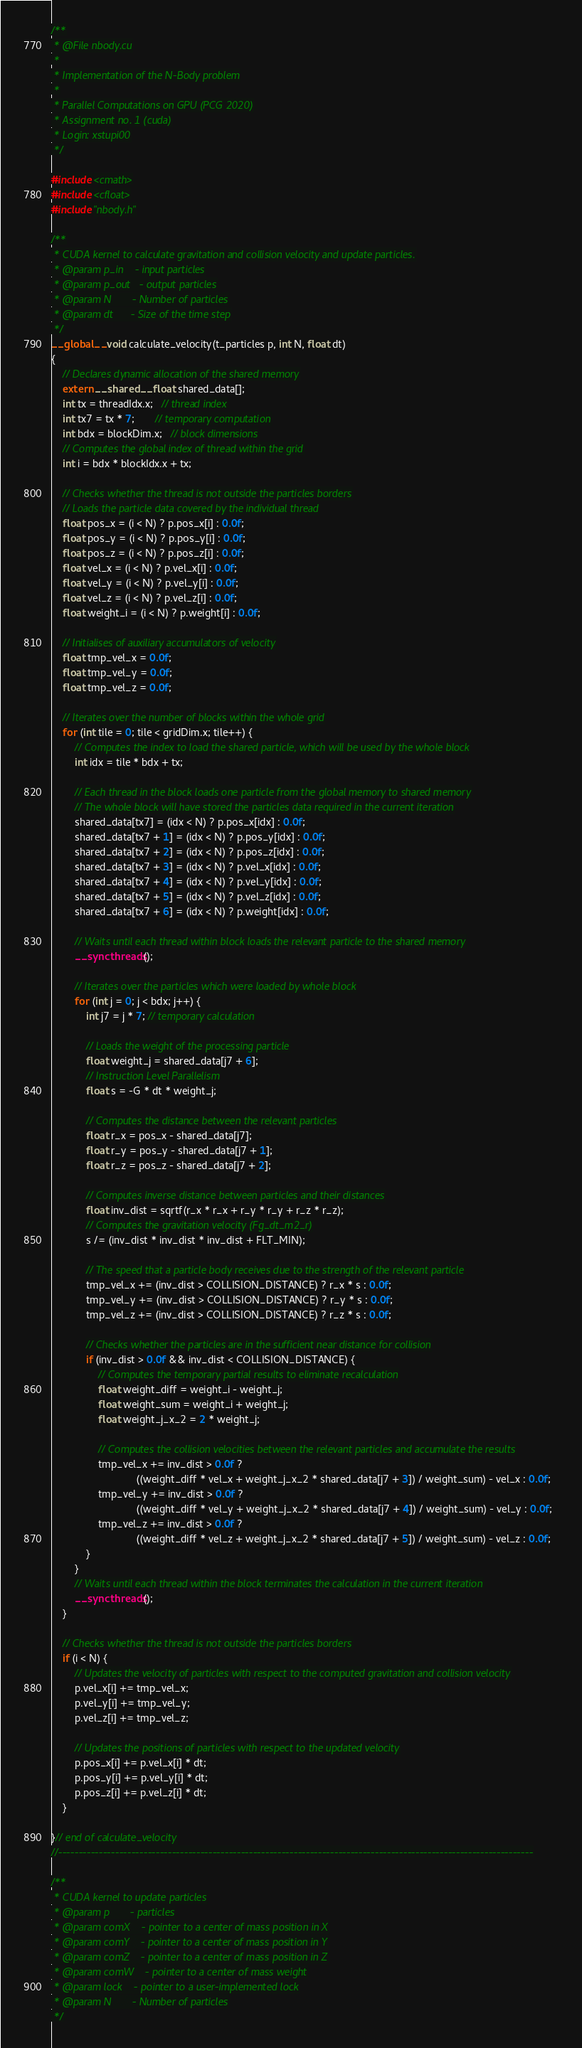Convert code to text. <code><loc_0><loc_0><loc_500><loc_500><_Cuda_>/**
 * @File nbody.cu
 *
 * Implementation of the N-Body problem
 *
 * Parallel Computations on GPU (PCG 2020)
 * Assignment no. 1 (cuda)
 * Login: xstupi00
 */

#include <cmath>
#include <cfloat>
#include "nbody.h"

/**
 * CUDA kernel to calculate gravitation and collision velocity and update particles.
 * @param p_in    - input particles
 * @param p_out   - output particles
 * @param N       - Number of particles
 * @param dt      - Size of the time step
 */
__global__ void calculate_velocity(t_particles p, int N, float dt)
{
    // Declares dynamic allocation of the shared memory
    extern __shared__ float shared_data[];
    int tx = threadIdx.x;   // thread index
    int tx7 = tx * 7;       // temporary computation
    int bdx = blockDim.x;   // block dimensions
    // Computes the global index of thread within the grid
    int i = bdx * blockIdx.x + tx;

    // Checks whether the thread is not outside the particles borders
    // Loads the particle data covered by the individual thread
    float pos_x = (i < N) ? p.pos_x[i] : 0.0f;
    float pos_y = (i < N) ? p.pos_y[i] : 0.0f;
    float pos_z = (i < N) ? p.pos_z[i] : 0.0f;
    float vel_x = (i < N) ? p.vel_x[i] : 0.0f;
    float vel_y = (i < N) ? p.vel_y[i] : 0.0f;
    float vel_z = (i < N) ? p.vel_z[i] : 0.0f;
    float weight_i = (i < N) ? p.weight[i] : 0.0f;

    // Initialises of auxiliary accumulators of velocity
    float tmp_vel_x = 0.0f;
    float tmp_vel_y = 0.0f;
    float tmp_vel_z = 0.0f;

    // Iterates over the number of blocks within the whole grid
    for (int tile = 0; tile < gridDim.x; tile++) {
        // Computes the index to load the shared particle, which will be used by the whole block
        int idx = tile * bdx + tx;

        // Each thread in the block loads one particle from the global memory to shared memory
        // The whole block will have stored the particles data required in the current iteration
        shared_data[tx7] = (idx < N) ? p.pos_x[idx] : 0.0f;
        shared_data[tx7 + 1] = (idx < N) ? p.pos_y[idx] : 0.0f;
        shared_data[tx7 + 2] = (idx < N) ? p.pos_z[idx] : 0.0f;
        shared_data[tx7 + 3] = (idx < N) ? p.vel_x[idx] : 0.0f;
        shared_data[tx7 + 4] = (idx < N) ? p.vel_y[idx] : 0.0f;
        shared_data[tx7 + 5] = (idx < N) ? p.vel_z[idx] : 0.0f;
        shared_data[tx7 + 6] = (idx < N) ? p.weight[idx] : 0.0f;

        // Waits until each thread within block loads the relevant particle to the shared memory
        __syncthreads();

        // Iterates over the particles which were loaded by whole block
        for (int j = 0; j < bdx; j++) {
            int j7 = j * 7; // temporary calculation

            // Loads the weight of the processing particle
            float weight_j = shared_data[j7 + 6];
            // Instruction Level Parallelism
            float s = -G * dt * weight_j;

            // Computes the distance between the relevant particles
            float r_x = pos_x - shared_data[j7];
            float r_y = pos_y - shared_data[j7 + 1];
            float r_z = pos_z - shared_data[j7 + 2];

            // Computes inverse distance between particles and their distances
            float inv_dist = sqrtf(r_x * r_x + r_y * r_y + r_z * r_z);
            // Computes the gravitation velocity (Fg_dt_m2_r)
            s /= (inv_dist * inv_dist * inv_dist + FLT_MIN);

            // The speed that a particle body receives due to the strength of the relevant particle
            tmp_vel_x += (inv_dist > COLLISION_DISTANCE) ? r_x * s : 0.0f;
            tmp_vel_y += (inv_dist > COLLISION_DISTANCE) ? r_y * s : 0.0f;
            tmp_vel_z += (inv_dist > COLLISION_DISTANCE) ? r_z * s : 0.0f;

            // Checks whether the particles are in the sufficient near distance for collision
            if (inv_dist > 0.0f && inv_dist < COLLISION_DISTANCE) {
                // Computes the temporary partial results to eliminate recalculation
                float weight_diff = weight_i - weight_j;
                float weight_sum = weight_i + weight_j;
                float weight_j_x_2 = 2 * weight_j;

                // Computes the collision velocities between the relevant particles and accumulate the results
                tmp_vel_x += inv_dist > 0.0f ?
                             ((weight_diff * vel_x + weight_j_x_2 * shared_data[j7 + 3]) / weight_sum) - vel_x : 0.0f;
                tmp_vel_y += inv_dist > 0.0f ?
                             ((weight_diff * vel_y + weight_j_x_2 * shared_data[j7 + 4]) / weight_sum) - vel_y : 0.0f;
                tmp_vel_z += inv_dist > 0.0f ?
                             ((weight_diff * vel_z + weight_j_x_2 * shared_data[j7 + 5]) / weight_sum) - vel_z : 0.0f;
            }
        }
        // Waits until each thread within the block terminates the calculation in the current iteration
        __syncthreads();
    }

    // Checks whether the thread is not outside the particles borders
    if (i < N) {
        // Updates the velocity of particles with respect to the computed gravitation and collision velocity
        p.vel_x[i] += tmp_vel_x;
        p.vel_y[i] += tmp_vel_y;
        p.vel_z[i] += tmp_vel_z;

        // Updates the positions of particles with respect to the updated velocity
        p.pos_x[i] += p.vel_x[i] * dt;
        p.pos_y[i] += p.vel_y[i] * dt;
        p.pos_z[i] += p.vel_z[i] * dt;
    }

}// end of calculate_velocity
//---------------------------------------------------------------------------------------------------------------------

/**
 * CUDA kernel to update particles
 * @param p       - particles
 * @param comX    - pointer to a center of mass position in X
 * @param comY    - pointer to a center of mass position in Y
 * @param comZ    - pointer to a center of mass position in Z
 * @param comW    - pointer to a center of mass weight
 * @param lock    - pointer to a user-implemented lock
 * @param N       - Number of particles
 */</code> 